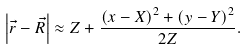Convert formula to latex. <formula><loc_0><loc_0><loc_500><loc_500>\left | \vec { r } - \vec { R } \right | \approx Z + \frac { \left ( x - X \right ) ^ { 2 } + \left ( y - Y \right ) ^ { 2 } } { 2 Z } .</formula> 